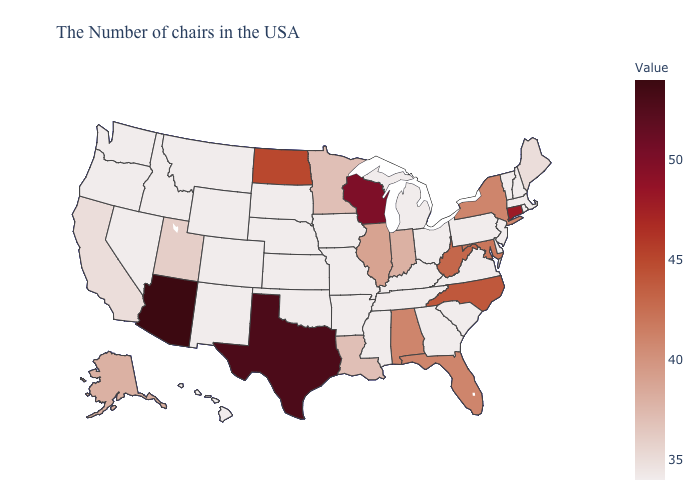Which states have the lowest value in the West?
Keep it brief. Wyoming, Colorado, New Mexico, Montana, Idaho, Nevada, Washington, Oregon, Hawaii. Among the states that border Wyoming , does South Dakota have the highest value?
Keep it brief. No. Which states hav the highest value in the Northeast?
Give a very brief answer. Connecticut. Does the map have missing data?
Write a very short answer. No. 